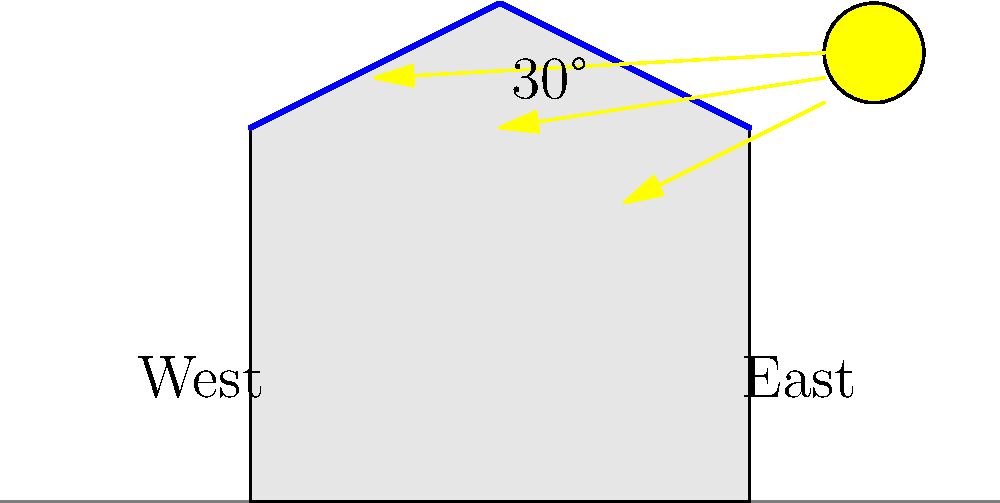In an eco-friendly building project in Ethiopia, you're tasked with optimizing solar panel placement. Given the diagram showing sun angles and roof orientations, which side of the roof would you recommend for installing solar panels to maximize energy generation throughout the year, and why? To determine the optimal placement of solar panels, we need to consider several factors:

1. Solar path: In the northern hemisphere, the sun's path is generally towards the south. Ethiopia, being just north of the equator, experiences a similar pattern.

2. Roof orientation: The diagram shows an east-west oriented building with a pitched roof.

3. Sun angle: The diagram indicates a 30° angle for the sun's rays, which is typical for lower latitudes like Ethiopia.

4. Energy generation: Maximum energy is generated when solar panels are perpendicular to the sun's rays.

5. Year-round performance: We need to consider the sun's position throughout the year, not just at one specific time.

Given these factors:

a) The east-facing roof will receive more direct sunlight in the morning.
b) The west-facing roof will receive more direct sunlight in the afternoon.
c) Due to Ethiopia's proximity to the equator, the sun's path doesn't vary as much seasonally as in higher latitudes.

Therefore, to maximize energy generation throughout the year, it's best to install solar panels on both sides of the roof. This approach ensures optimal energy capture from morning to evening and accounts for seasonal variations.

If only one side must be chosen, the west-facing roof would be slightly preferable. This is because:
1) Afternoon sun is typically stronger than morning sun.
2) Energy demand is often higher in the afternoon, aligning with peak generation.
Answer: Both roof sides, with a slight preference for the west-facing side if only one can be chosen. 